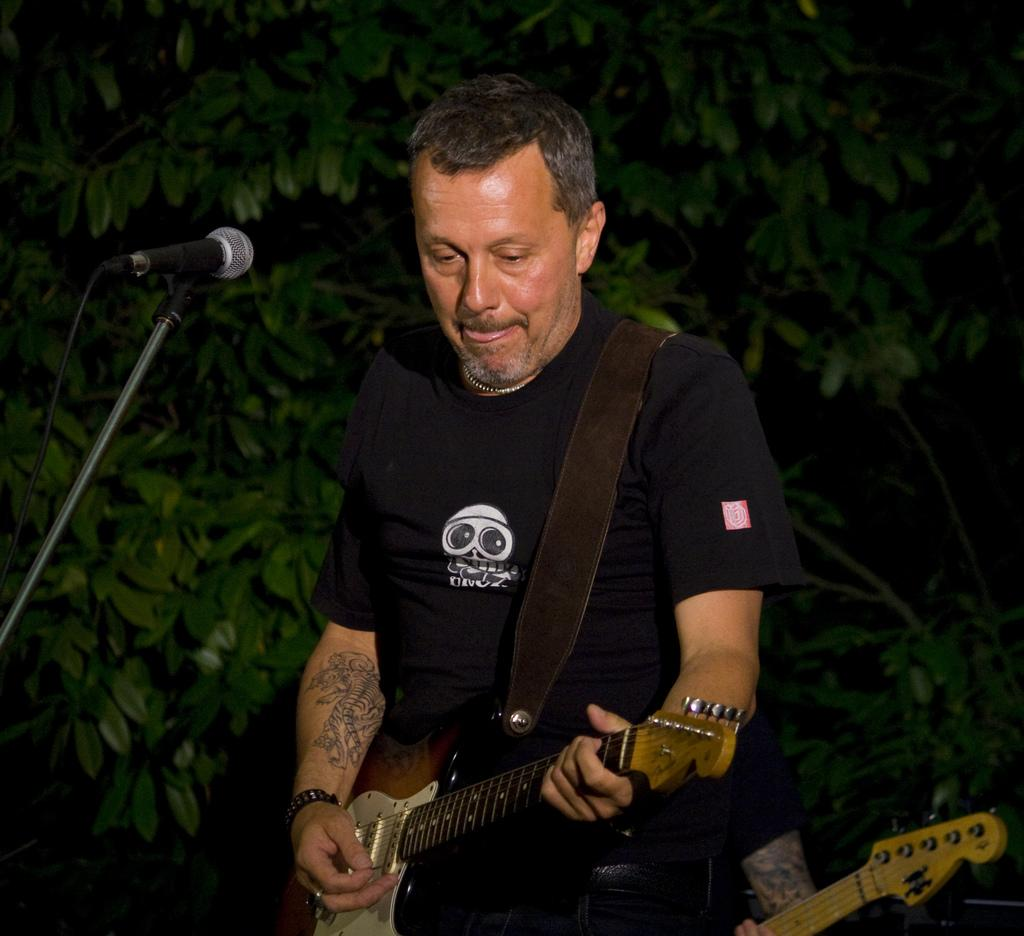What is the main activity of the person in the image? The person in the image is standing and playing a guitar. Can you describe the position of the second person in the image? The second person is holding a guitar behind the first person. What can be seen in the background of the image? Trees are visible in the background. What equipment is present for amplifying sound in the image? There is a microphone with a stand in the image. What type of order is the person holding the guitar about to place for a crate? There is no mention of an order or a crate in the image, so this question cannot be answered definitively. 